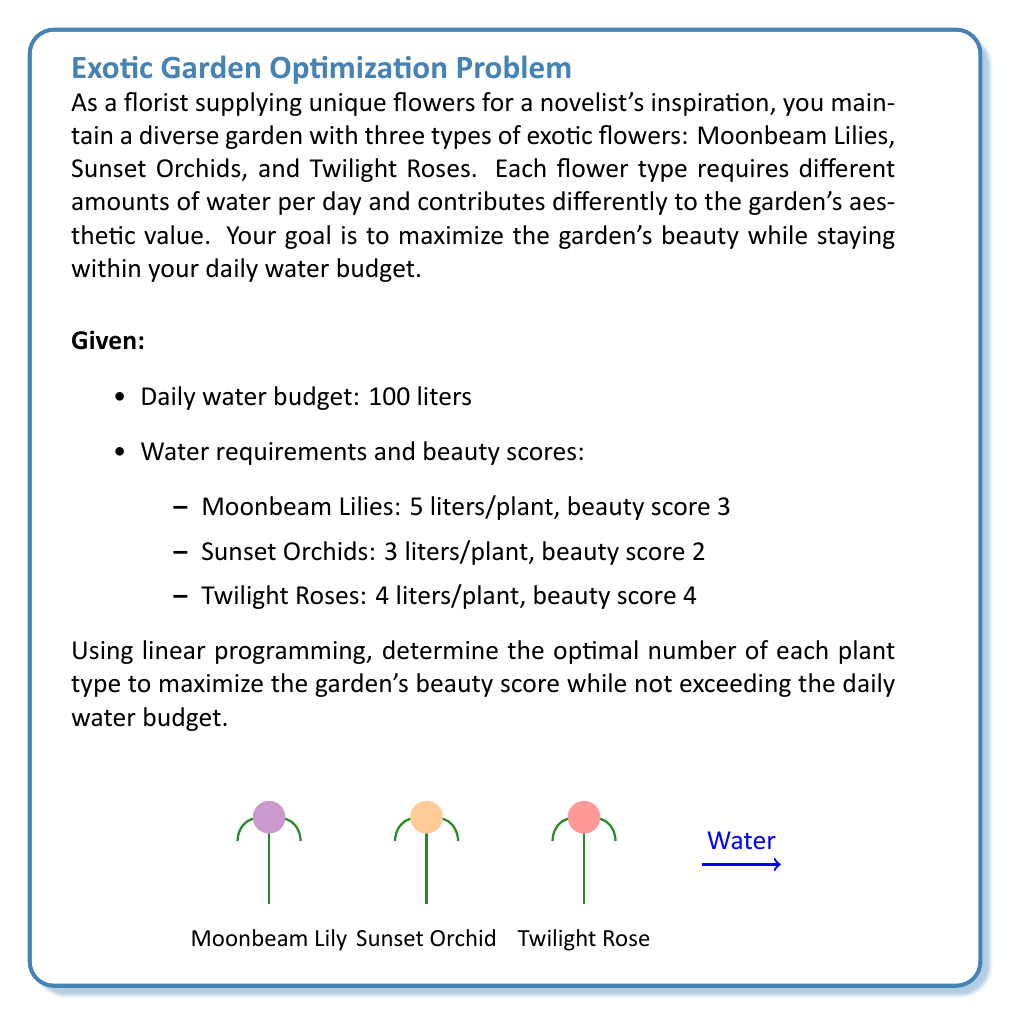Could you help me with this problem? Let's solve this problem step by step using linear programming:

1) Define variables:
   Let $x$ = number of Moonbeam Lilies
       $y$ = number of Sunset Orchids
       $z$ = number of Twilight Roses

2) Objective function:
   Maximize beauty score: $3x + 2y + 4z$

3) Constraints:
   Water budget: $5x + 3y + 4z \leq 100$
   Non-negativity: $x \geq 0, y \geq 0, z \geq 0$

4) Set up the linear programming problem:
   Maximize: $3x + 2y + 4z$
   Subject to:
   $5x + 3y + 4z \leq 100$
   $x, y, z \geq 0$

5) Solve using the simplex method or graphical method. Here, we'll use the concept of corner points:

   Corner points of the feasible region:
   (0, 0, 25), (20, 0, 0), (0, 33.33, 0), (0, 0, 25), (10, 0, 12.5), (0, 16.67, 12.5)

6) Evaluate the objective function at each corner point:
   (0, 0, 25): $3(0) + 2(0) + 4(25) = 100$
   (20, 0, 0): $3(20) + 2(0) + 4(0) = 60$
   (0, 33.33, 0): $3(0) + 2(33.33) + 4(0) = 66.66$
   (10, 0, 12.5): $3(10) + 2(0) + 4(12.5) = 80$
   (0, 16.67, 12.5): $3(0) + 2(16.67) + 4(12.5) = 83.34$

7) The maximum value occurs at (0, 0, 25), which gives a beauty score of 100.

Therefore, the optimal solution is to plant 25 Twilight Roses, and no Moonbeam Lilies or Sunset Orchids.
Answer: 25 Twilight Roses, 0 Moonbeam Lilies, 0 Sunset Orchids 